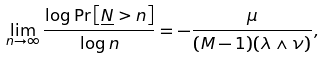Convert formula to latex. <formula><loc_0><loc_0><loc_500><loc_500>\lim _ { n \rightarrow \infty } \frac { \log \Pr \left [ \underline { N } > n \right ] } { \log n } = - \frac { \mu } { ( M - 1 ) ( \lambda \wedge \nu ) } ,</formula> 